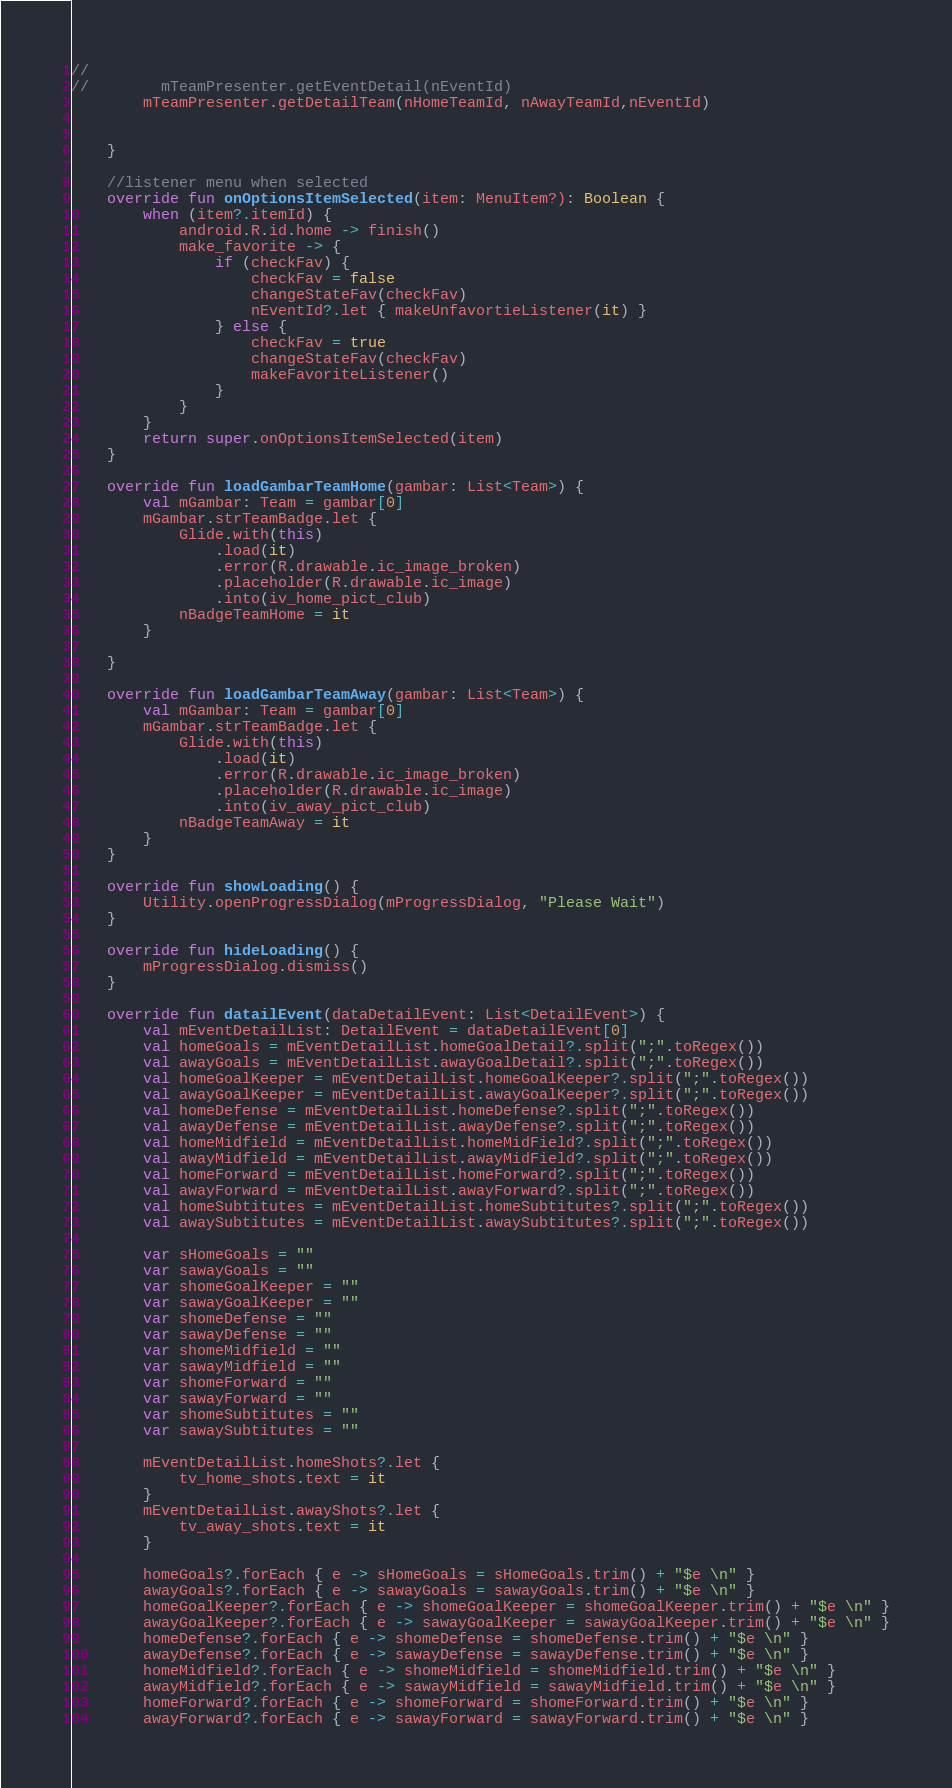Convert code to text. <code><loc_0><loc_0><loc_500><loc_500><_Kotlin_>//
//        mTeamPresenter.getEventDetail(nEventId)
        mTeamPresenter.getDetailTeam(nHomeTeamId, nAwayTeamId,nEventId)


    }

    //listener menu when selected
    override fun onOptionsItemSelected(item: MenuItem?): Boolean {
        when (item?.itemId) {
            android.R.id.home -> finish()
            make_favorite -> {
                if (checkFav) {
                    checkFav = false
                    changeStateFav(checkFav)
                    nEventId?.let { makeUnfavortieListener(it) }
                } else {
                    checkFav = true
                    changeStateFav(checkFav)
                    makeFavoriteListener()
                }
            }
        }
        return super.onOptionsItemSelected(item)
    }

    override fun loadGambarTeamHome(gambar: List<Team>) {
        val mGambar: Team = gambar[0]
        mGambar.strTeamBadge.let {
            Glide.with(this)
                .load(it)
                .error(R.drawable.ic_image_broken)
                .placeholder(R.drawable.ic_image)
                .into(iv_home_pict_club)
            nBadgeTeamHome = it
        }

    }

    override fun loadGambarTeamAway(gambar: List<Team>) {
        val mGambar: Team = gambar[0]
        mGambar.strTeamBadge.let {
            Glide.with(this)
                .load(it)
                .error(R.drawable.ic_image_broken)
                .placeholder(R.drawable.ic_image)
                .into(iv_away_pict_club)
            nBadgeTeamAway = it
        }
    }

    override fun showLoading() {
        Utility.openProgressDialog(mProgressDialog, "Please Wait")
    }

    override fun hideLoading() {
        mProgressDialog.dismiss()
    }

    override fun datailEvent(dataDetailEvent: List<DetailEvent>) {
        val mEventDetailList: DetailEvent = dataDetailEvent[0]
        val homeGoals = mEventDetailList.homeGoalDetail?.split(";".toRegex())
        val awayGoals = mEventDetailList.awayGoalDetail?.split(";".toRegex())
        val homeGoalKeeper = mEventDetailList.homeGoalKeeper?.split(";".toRegex())
        val awayGoalKeeper = mEventDetailList.awayGoalKeeper?.split(";".toRegex())
        val homeDefense = mEventDetailList.homeDefense?.split(";".toRegex())
        val awayDefense = mEventDetailList.awayDefense?.split(";".toRegex())
        val homeMidfield = mEventDetailList.homeMidField?.split(";".toRegex())
        val awayMidfield = mEventDetailList.awayMidField?.split(";".toRegex())
        val homeForward = mEventDetailList.homeForward?.split(";".toRegex())
        val awayForward = mEventDetailList.awayForward?.split(";".toRegex())
        val homeSubtitutes = mEventDetailList.homeSubtitutes?.split(";".toRegex())
        val awaySubtitutes = mEventDetailList.awaySubtitutes?.split(";".toRegex())

        var sHomeGoals = ""
        var sawayGoals = ""
        var shomeGoalKeeper = ""
        var sawayGoalKeeper = ""
        var shomeDefense = ""
        var sawayDefense = ""
        var shomeMidfield = ""
        var sawayMidfield = ""
        var shomeForward = ""
        var sawayForward = ""
        var shomeSubtitutes = ""
        var sawaySubtitutes = ""

        mEventDetailList.homeShots?.let {
            tv_home_shots.text = it
        }
        mEventDetailList.awayShots?.let {
            tv_away_shots.text = it
        }

        homeGoals?.forEach { e -> sHomeGoals = sHomeGoals.trim() + "$e \n" }
        awayGoals?.forEach { e -> sawayGoals = sawayGoals.trim() + "$e \n" }
        homeGoalKeeper?.forEach { e -> shomeGoalKeeper = shomeGoalKeeper.trim() + "$e \n" }
        awayGoalKeeper?.forEach { e -> sawayGoalKeeper = sawayGoalKeeper.trim() + "$e \n" }
        homeDefense?.forEach { e -> shomeDefense = shomeDefense.trim() + "$e \n" }
        awayDefense?.forEach { e -> sawayDefense = sawayDefense.trim() + "$e \n" }
        homeMidfield?.forEach { e -> shomeMidfield = shomeMidfield.trim() + "$e \n" }
        awayMidfield?.forEach { e -> sawayMidfield = sawayMidfield.trim() + "$e \n" }
        homeForward?.forEach { e -> shomeForward = shomeForward.trim() + "$e \n" }
        awayForward?.forEach { e -> sawayForward = sawayForward.trim() + "$e \n" }</code> 